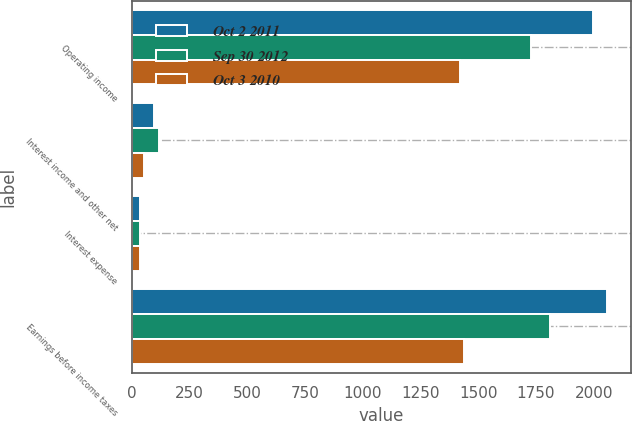Convert chart to OTSL. <chart><loc_0><loc_0><loc_500><loc_500><stacked_bar_chart><ecel><fcel>Operating income<fcel>Interest income and other net<fcel>Interest expense<fcel>Earnings before income taxes<nl><fcel>Oct 2 2011<fcel>1997.4<fcel>94.4<fcel>32.7<fcel>2059.1<nl><fcel>Sep 30 2012<fcel>1728.5<fcel>115.9<fcel>33.3<fcel>1811.1<nl><fcel>Oct 3 2010<fcel>1419.4<fcel>50.3<fcel>32.7<fcel>1437<nl></chart> 